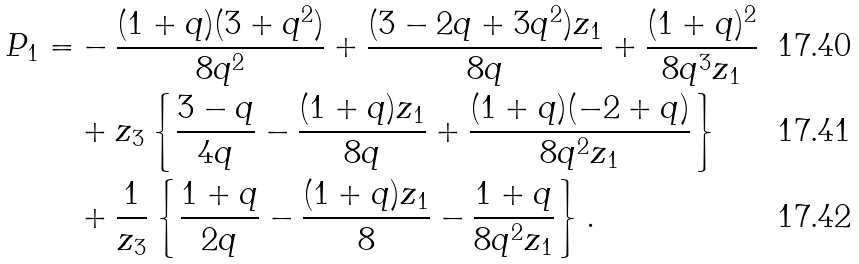Convert formula to latex. <formula><loc_0><loc_0><loc_500><loc_500>P _ { 1 } = & - \frac { ( 1 + q ) ( 3 + q ^ { 2 } ) } { 8 q ^ { 2 } } + \frac { ( 3 - 2 q + 3 q ^ { 2 } ) z _ { 1 } } { 8 q } + \frac { ( 1 + q ) ^ { 2 } } { 8 q ^ { 3 } z _ { 1 } } \\ & + z _ { 3 } \left \{ \frac { 3 - q } { 4 q } - \frac { ( 1 + q ) z _ { 1 } } { 8 q } + \frac { ( 1 + q ) ( - 2 + q ) } { 8 q ^ { 2 } z _ { 1 } } \right \} \\ & + \frac { 1 } { z _ { 3 } } \left \{ \frac { 1 + q } { 2 q } - \frac { ( 1 + q ) z _ { 1 } } { 8 } - \frac { 1 + q } { 8 q ^ { 2 } z _ { 1 } } \right \} .</formula> 